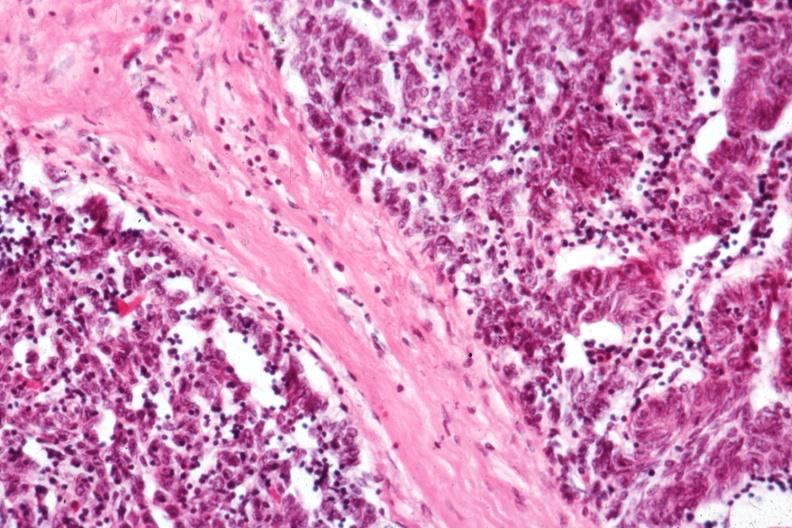s thymus present?
Answer the question using a single word or phrase. Yes 